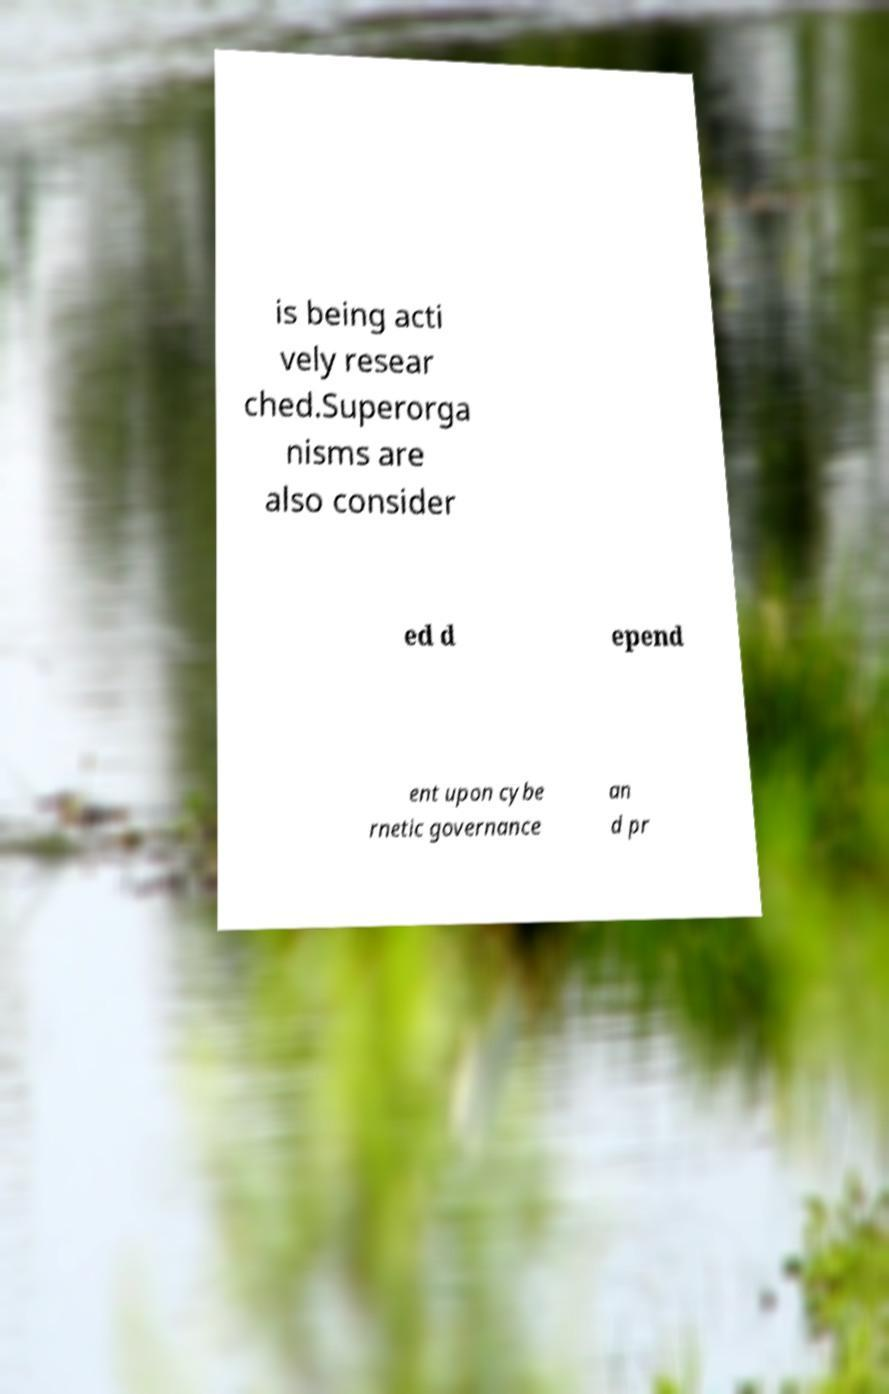For documentation purposes, I need the text within this image transcribed. Could you provide that? is being acti vely resear ched.Superorga nisms are also consider ed d epend ent upon cybe rnetic governance an d pr 